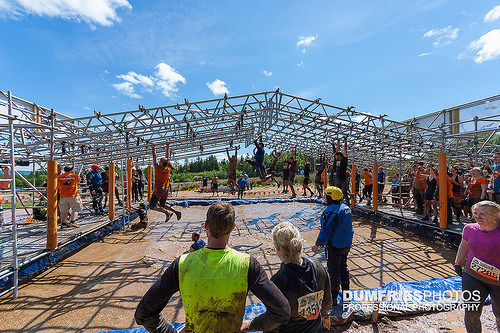<image>
Is the boy on the bars? Yes. Looking at the image, I can see the boy is positioned on top of the bars, with the bars providing support. Is there a person to the left of the man? Yes. From this viewpoint, the person is positioned to the left side relative to the man. Where is the man in relation to the pole? Is it to the right of the pole? Yes. From this viewpoint, the man is positioned to the right side relative to the pole. 